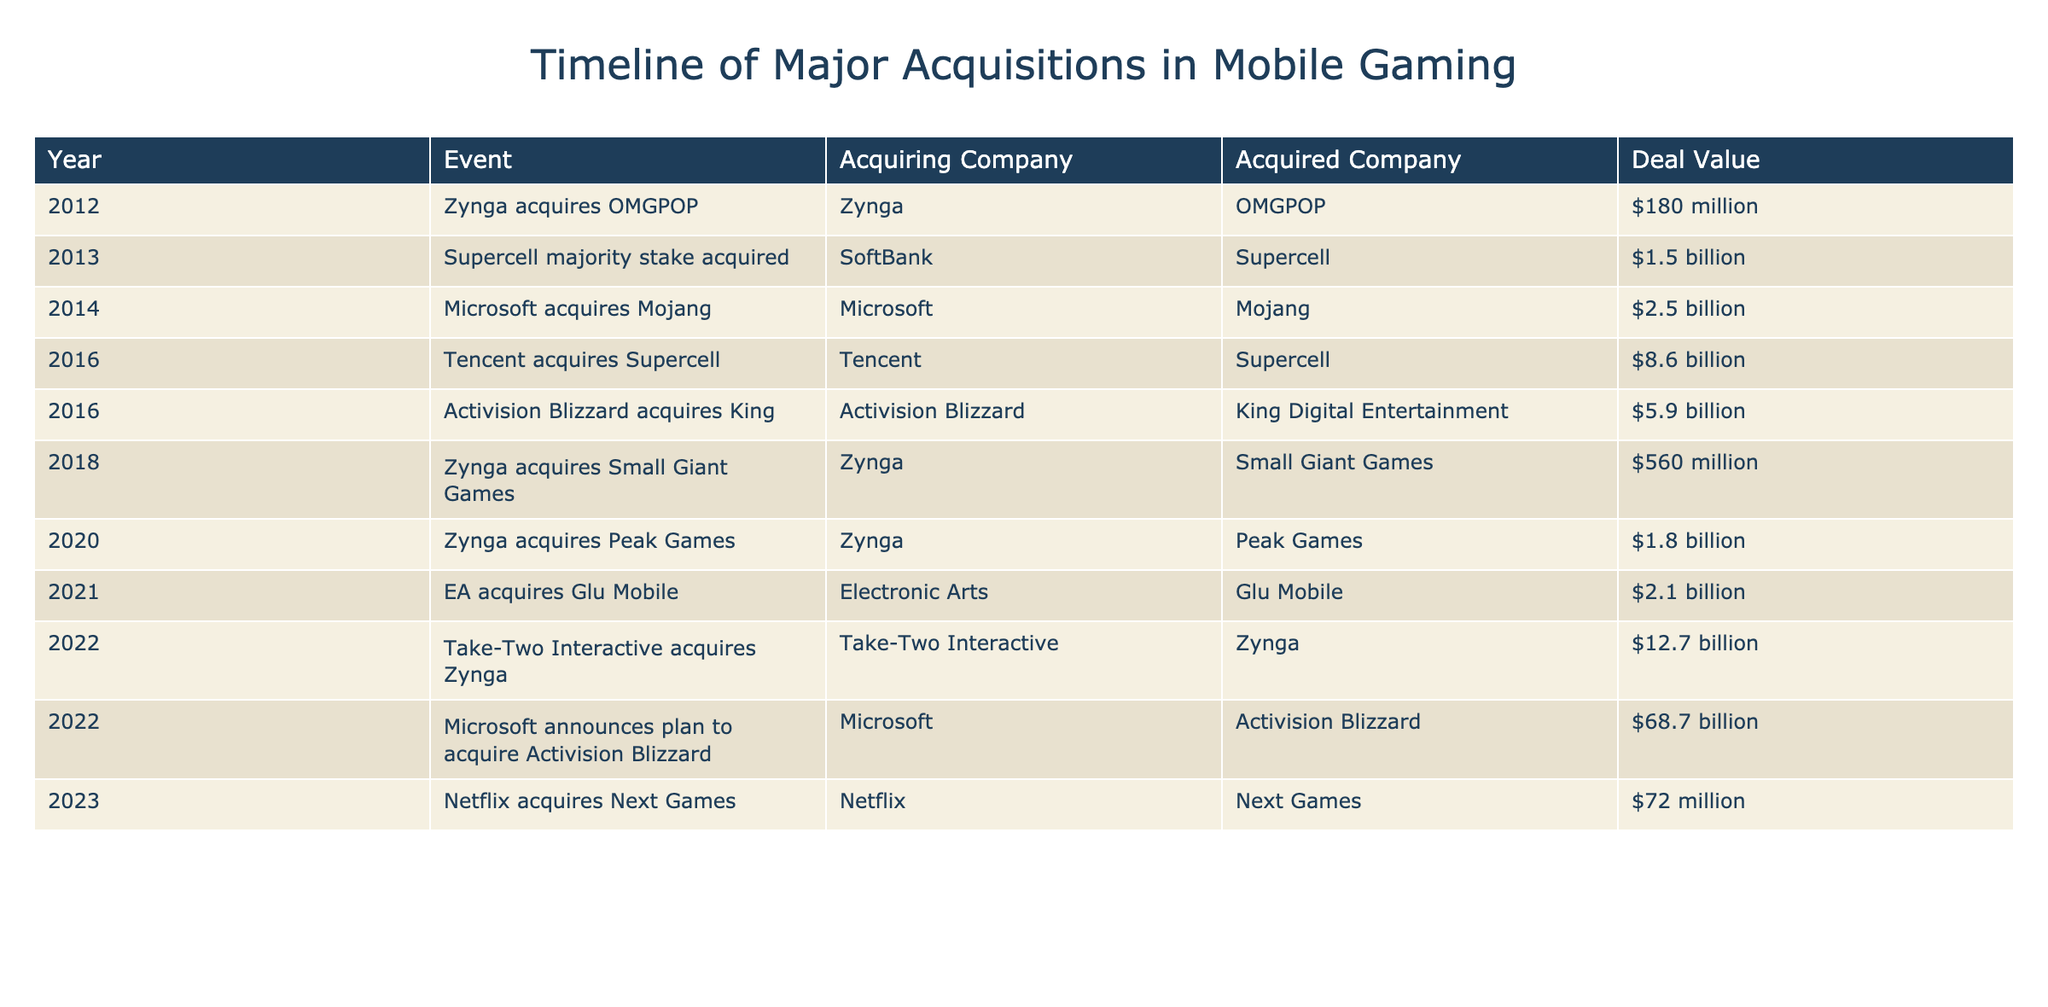What year did Tencent acquire Supercell? The table lists events sorted by year. Looking for Tencent's acquisition of Supercell, we find it in 2016.
Answer: 2016 What was the total deal value of the acquisitions made by Zynga? Zynga made three acquisitions: OMGPOP for $180 million, Small Giant Games for $560 million, and Peak Games for $1.8 billion. Summing these values gives $180 + $560 + $1800 = $2540 million.
Answer: $2.54 billion Did Electronic Arts acquire a company in 2021? The table shows that Electronic Arts acquired Glu Mobile in 2021. This confirms that Electronic Arts did make an acquisition that year.
Answer: Yes Which company had the highest acquisition deal value on the list? Examining the Deal Value column, Microsoft announced the plan to acquire Activision Blizzard for $68.7 billion in 2022, which is the highest value on the table.
Answer: Microsoft ($68.7 billion) In what year did Take-Two Interactive acquire Zynga and what was the deal value? The table indicates that Take-Two Interactive acquired Zynga in 2022 for a deal value of $12.7 billion.
Answer: 2022, $12.7 billion How many acquisitions listed in the table were made by Zynga? By checking the table, we see that Zynga made three acquisitions: OMGPOP, Small Giant Games, and Peak Games. Counting these, we find there are three acquisitions made by Zynga.
Answer: 3 Was the acquisition of Mojang by Microsoft in 2014 more or less than $3 billion? The table shows that Microsoft acquired Mojang for $2.5 billion, which is less than $3 billion.
Answer: Less What is the average deal value of acquisitions made in 2016? The table lists two acquisitions in 2016: Tencent acquiring Supercell for $8.6 billion and Activision Blizzard acquiring King for $5.9 billion. To find the average, we sum them: $8.6 billion + $5.9 billion = $14.5 billion and divide by 2, giving an average of $7.25 billion.
Answer: $7.25 billion Which acquiring company had the most acquisitions in the timeline? Analyzing the table, we see multiple entries for Zynga (three acquisitions). Other companies do not match this count. Therefore, Zynga had the most acquisitions listed.
Answer: Zynga What was the total deal value of acquisitions made in 2022? The table shows two acquisitions in 2022: Take-Two Interactive acquiring Zynga for $12.7 billion and Microsoft acquiring Activision Blizzard for $68.7 billion. Summing these values gives $12.7 billion + $68.7 billion = $81.4 billion.
Answer: $81.4 billion 